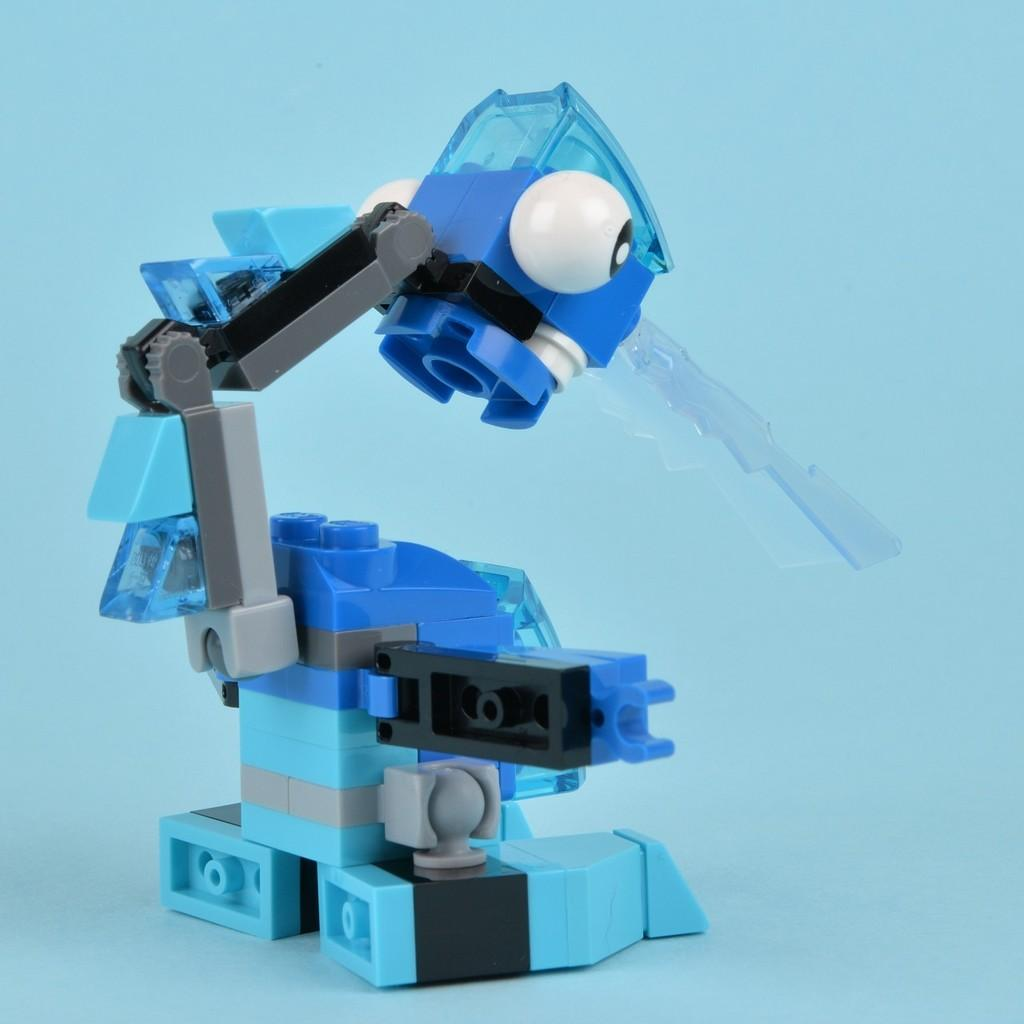What type of toy is present in the image? There is a toy made of building blocks in the image. What is the toy placed on? The toy is placed on a blue color platform. What type of vest is the coach wearing in the image? There is no coach or vest present in the image; it only features a toy made of building blocks on a blue color platform. 